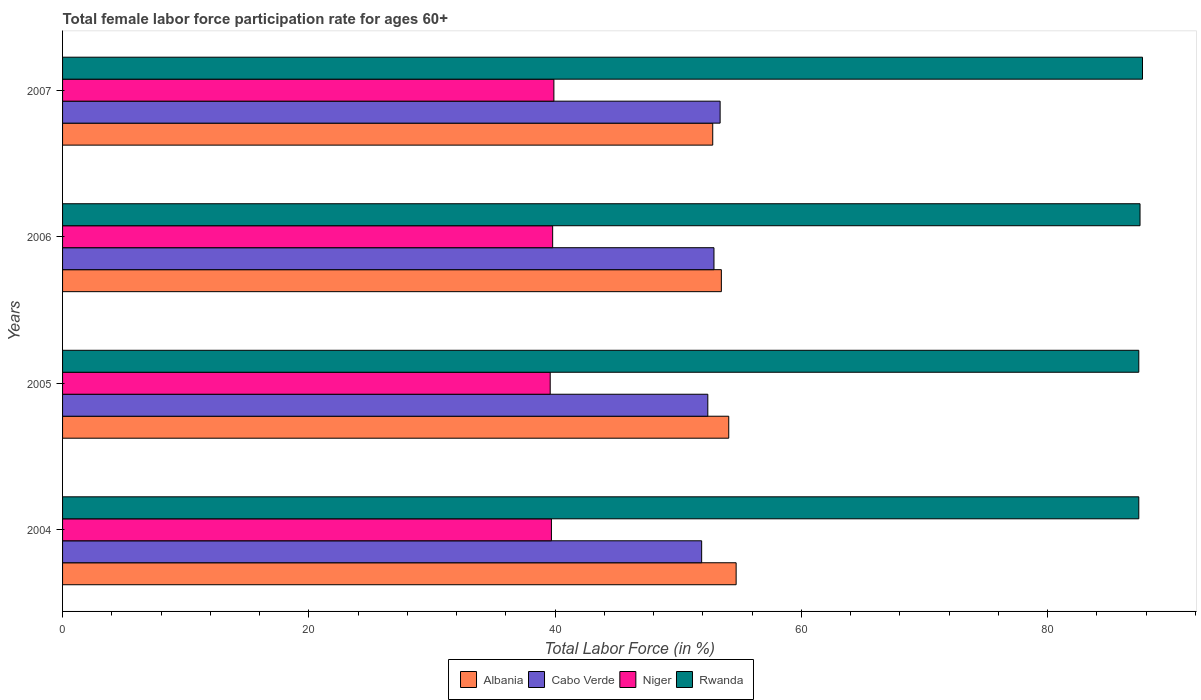How many groups of bars are there?
Your answer should be compact. 4. Are the number of bars on each tick of the Y-axis equal?
Provide a short and direct response. Yes. What is the female labor force participation rate in Cabo Verde in 2005?
Offer a very short reply. 52.4. Across all years, what is the maximum female labor force participation rate in Albania?
Your answer should be very brief. 54.7. Across all years, what is the minimum female labor force participation rate in Niger?
Ensure brevity in your answer.  39.6. In which year was the female labor force participation rate in Niger minimum?
Your response must be concise. 2005. What is the total female labor force participation rate in Rwanda in the graph?
Give a very brief answer. 350. What is the difference between the female labor force participation rate in Albania in 2005 and that in 2006?
Give a very brief answer. 0.6. What is the difference between the female labor force participation rate in Albania in 2004 and the female labor force participation rate in Rwanda in 2006?
Keep it short and to the point. -32.8. What is the average female labor force participation rate in Rwanda per year?
Keep it short and to the point. 87.5. In the year 2005, what is the difference between the female labor force participation rate in Niger and female labor force participation rate in Rwanda?
Offer a very short reply. -47.8. What is the ratio of the female labor force participation rate in Rwanda in 2006 to that in 2007?
Your response must be concise. 1. Is the female labor force participation rate in Niger in 2006 less than that in 2007?
Your response must be concise. Yes. What is the difference between the highest and the second highest female labor force participation rate in Niger?
Provide a short and direct response. 0.1. What is the difference between the highest and the lowest female labor force participation rate in Albania?
Make the answer very short. 1.9. Is it the case that in every year, the sum of the female labor force participation rate in Niger and female labor force participation rate in Rwanda is greater than the sum of female labor force participation rate in Albania and female labor force participation rate in Cabo Verde?
Your response must be concise. No. What does the 2nd bar from the top in 2006 represents?
Make the answer very short. Niger. What does the 2nd bar from the bottom in 2007 represents?
Ensure brevity in your answer.  Cabo Verde. Is it the case that in every year, the sum of the female labor force participation rate in Albania and female labor force participation rate in Cabo Verde is greater than the female labor force participation rate in Niger?
Offer a terse response. Yes. How many years are there in the graph?
Your response must be concise. 4. Does the graph contain grids?
Provide a succinct answer. No. Where does the legend appear in the graph?
Keep it short and to the point. Bottom center. How many legend labels are there?
Give a very brief answer. 4. What is the title of the graph?
Make the answer very short. Total female labor force participation rate for ages 60+. What is the label or title of the Y-axis?
Ensure brevity in your answer.  Years. What is the Total Labor Force (in %) in Albania in 2004?
Your answer should be compact. 54.7. What is the Total Labor Force (in %) of Cabo Verde in 2004?
Give a very brief answer. 51.9. What is the Total Labor Force (in %) of Niger in 2004?
Ensure brevity in your answer.  39.7. What is the Total Labor Force (in %) in Rwanda in 2004?
Provide a succinct answer. 87.4. What is the Total Labor Force (in %) of Albania in 2005?
Ensure brevity in your answer.  54.1. What is the Total Labor Force (in %) of Cabo Verde in 2005?
Provide a short and direct response. 52.4. What is the Total Labor Force (in %) of Niger in 2005?
Make the answer very short. 39.6. What is the Total Labor Force (in %) of Rwanda in 2005?
Give a very brief answer. 87.4. What is the Total Labor Force (in %) of Albania in 2006?
Give a very brief answer. 53.5. What is the Total Labor Force (in %) in Cabo Verde in 2006?
Your answer should be compact. 52.9. What is the Total Labor Force (in %) in Niger in 2006?
Your answer should be compact. 39.8. What is the Total Labor Force (in %) in Rwanda in 2006?
Provide a short and direct response. 87.5. What is the Total Labor Force (in %) of Albania in 2007?
Keep it short and to the point. 52.8. What is the Total Labor Force (in %) of Cabo Verde in 2007?
Your answer should be very brief. 53.4. What is the Total Labor Force (in %) in Niger in 2007?
Make the answer very short. 39.9. What is the Total Labor Force (in %) in Rwanda in 2007?
Give a very brief answer. 87.7. Across all years, what is the maximum Total Labor Force (in %) of Albania?
Give a very brief answer. 54.7. Across all years, what is the maximum Total Labor Force (in %) of Cabo Verde?
Your response must be concise. 53.4. Across all years, what is the maximum Total Labor Force (in %) of Niger?
Your response must be concise. 39.9. Across all years, what is the maximum Total Labor Force (in %) of Rwanda?
Make the answer very short. 87.7. Across all years, what is the minimum Total Labor Force (in %) of Albania?
Ensure brevity in your answer.  52.8. Across all years, what is the minimum Total Labor Force (in %) of Cabo Verde?
Offer a very short reply. 51.9. Across all years, what is the minimum Total Labor Force (in %) of Niger?
Offer a terse response. 39.6. Across all years, what is the minimum Total Labor Force (in %) of Rwanda?
Your response must be concise. 87.4. What is the total Total Labor Force (in %) in Albania in the graph?
Give a very brief answer. 215.1. What is the total Total Labor Force (in %) in Cabo Verde in the graph?
Offer a very short reply. 210.6. What is the total Total Labor Force (in %) in Niger in the graph?
Offer a very short reply. 159. What is the total Total Labor Force (in %) of Rwanda in the graph?
Keep it short and to the point. 350. What is the difference between the Total Labor Force (in %) of Cabo Verde in 2004 and that in 2005?
Provide a short and direct response. -0.5. What is the difference between the Total Labor Force (in %) in Rwanda in 2004 and that in 2005?
Keep it short and to the point. 0. What is the difference between the Total Labor Force (in %) in Niger in 2004 and that in 2006?
Provide a short and direct response. -0.1. What is the difference between the Total Labor Force (in %) in Cabo Verde in 2004 and that in 2007?
Your answer should be compact. -1.5. What is the difference between the Total Labor Force (in %) of Niger in 2004 and that in 2007?
Your answer should be compact. -0.2. What is the difference between the Total Labor Force (in %) of Albania in 2005 and that in 2007?
Your answer should be compact. 1.3. What is the difference between the Total Labor Force (in %) in Cabo Verde in 2006 and that in 2007?
Make the answer very short. -0.5. What is the difference between the Total Labor Force (in %) in Niger in 2006 and that in 2007?
Offer a very short reply. -0.1. What is the difference between the Total Labor Force (in %) of Albania in 2004 and the Total Labor Force (in %) of Niger in 2005?
Your answer should be compact. 15.1. What is the difference between the Total Labor Force (in %) in Albania in 2004 and the Total Labor Force (in %) in Rwanda in 2005?
Offer a terse response. -32.7. What is the difference between the Total Labor Force (in %) of Cabo Verde in 2004 and the Total Labor Force (in %) of Rwanda in 2005?
Offer a very short reply. -35.5. What is the difference between the Total Labor Force (in %) of Niger in 2004 and the Total Labor Force (in %) of Rwanda in 2005?
Provide a succinct answer. -47.7. What is the difference between the Total Labor Force (in %) of Albania in 2004 and the Total Labor Force (in %) of Cabo Verde in 2006?
Provide a succinct answer. 1.8. What is the difference between the Total Labor Force (in %) of Albania in 2004 and the Total Labor Force (in %) of Niger in 2006?
Your answer should be compact. 14.9. What is the difference between the Total Labor Force (in %) in Albania in 2004 and the Total Labor Force (in %) in Rwanda in 2006?
Your answer should be very brief. -32.8. What is the difference between the Total Labor Force (in %) in Cabo Verde in 2004 and the Total Labor Force (in %) in Niger in 2006?
Make the answer very short. 12.1. What is the difference between the Total Labor Force (in %) in Cabo Verde in 2004 and the Total Labor Force (in %) in Rwanda in 2006?
Make the answer very short. -35.6. What is the difference between the Total Labor Force (in %) in Niger in 2004 and the Total Labor Force (in %) in Rwanda in 2006?
Provide a short and direct response. -47.8. What is the difference between the Total Labor Force (in %) in Albania in 2004 and the Total Labor Force (in %) in Niger in 2007?
Offer a terse response. 14.8. What is the difference between the Total Labor Force (in %) in Albania in 2004 and the Total Labor Force (in %) in Rwanda in 2007?
Provide a succinct answer. -33. What is the difference between the Total Labor Force (in %) of Cabo Verde in 2004 and the Total Labor Force (in %) of Rwanda in 2007?
Your answer should be very brief. -35.8. What is the difference between the Total Labor Force (in %) of Niger in 2004 and the Total Labor Force (in %) of Rwanda in 2007?
Give a very brief answer. -48. What is the difference between the Total Labor Force (in %) in Albania in 2005 and the Total Labor Force (in %) in Rwanda in 2006?
Offer a very short reply. -33.4. What is the difference between the Total Labor Force (in %) of Cabo Verde in 2005 and the Total Labor Force (in %) of Niger in 2006?
Keep it short and to the point. 12.6. What is the difference between the Total Labor Force (in %) in Cabo Verde in 2005 and the Total Labor Force (in %) in Rwanda in 2006?
Ensure brevity in your answer.  -35.1. What is the difference between the Total Labor Force (in %) of Niger in 2005 and the Total Labor Force (in %) of Rwanda in 2006?
Provide a succinct answer. -47.9. What is the difference between the Total Labor Force (in %) of Albania in 2005 and the Total Labor Force (in %) of Niger in 2007?
Your answer should be very brief. 14.2. What is the difference between the Total Labor Force (in %) in Albania in 2005 and the Total Labor Force (in %) in Rwanda in 2007?
Offer a terse response. -33.6. What is the difference between the Total Labor Force (in %) of Cabo Verde in 2005 and the Total Labor Force (in %) of Niger in 2007?
Offer a very short reply. 12.5. What is the difference between the Total Labor Force (in %) of Cabo Verde in 2005 and the Total Labor Force (in %) of Rwanda in 2007?
Provide a short and direct response. -35.3. What is the difference between the Total Labor Force (in %) in Niger in 2005 and the Total Labor Force (in %) in Rwanda in 2007?
Your answer should be compact. -48.1. What is the difference between the Total Labor Force (in %) of Albania in 2006 and the Total Labor Force (in %) of Niger in 2007?
Give a very brief answer. 13.6. What is the difference between the Total Labor Force (in %) in Albania in 2006 and the Total Labor Force (in %) in Rwanda in 2007?
Your answer should be very brief. -34.2. What is the difference between the Total Labor Force (in %) of Cabo Verde in 2006 and the Total Labor Force (in %) of Rwanda in 2007?
Keep it short and to the point. -34.8. What is the difference between the Total Labor Force (in %) in Niger in 2006 and the Total Labor Force (in %) in Rwanda in 2007?
Provide a succinct answer. -47.9. What is the average Total Labor Force (in %) of Albania per year?
Your answer should be very brief. 53.77. What is the average Total Labor Force (in %) in Cabo Verde per year?
Offer a very short reply. 52.65. What is the average Total Labor Force (in %) in Niger per year?
Your answer should be very brief. 39.75. What is the average Total Labor Force (in %) of Rwanda per year?
Give a very brief answer. 87.5. In the year 2004, what is the difference between the Total Labor Force (in %) of Albania and Total Labor Force (in %) of Rwanda?
Ensure brevity in your answer.  -32.7. In the year 2004, what is the difference between the Total Labor Force (in %) of Cabo Verde and Total Labor Force (in %) of Niger?
Your response must be concise. 12.2. In the year 2004, what is the difference between the Total Labor Force (in %) of Cabo Verde and Total Labor Force (in %) of Rwanda?
Provide a short and direct response. -35.5. In the year 2004, what is the difference between the Total Labor Force (in %) of Niger and Total Labor Force (in %) of Rwanda?
Give a very brief answer. -47.7. In the year 2005, what is the difference between the Total Labor Force (in %) in Albania and Total Labor Force (in %) in Cabo Verde?
Offer a very short reply. 1.7. In the year 2005, what is the difference between the Total Labor Force (in %) of Albania and Total Labor Force (in %) of Niger?
Provide a succinct answer. 14.5. In the year 2005, what is the difference between the Total Labor Force (in %) of Albania and Total Labor Force (in %) of Rwanda?
Your response must be concise. -33.3. In the year 2005, what is the difference between the Total Labor Force (in %) in Cabo Verde and Total Labor Force (in %) in Rwanda?
Your answer should be compact. -35. In the year 2005, what is the difference between the Total Labor Force (in %) of Niger and Total Labor Force (in %) of Rwanda?
Provide a succinct answer. -47.8. In the year 2006, what is the difference between the Total Labor Force (in %) in Albania and Total Labor Force (in %) in Rwanda?
Provide a succinct answer. -34. In the year 2006, what is the difference between the Total Labor Force (in %) of Cabo Verde and Total Labor Force (in %) of Rwanda?
Give a very brief answer. -34.6. In the year 2006, what is the difference between the Total Labor Force (in %) in Niger and Total Labor Force (in %) in Rwanda?
Ensure brevity in your answer.  -47.7. In the year 2007, what is the difference between the Total Labor Force (in %) of Albania and Total Labor Force (in %) of Niger?
Make the answer very short. 12.9. In the year 2007, what is the difference between the Total Labor Force (in %) in Albania and Total Labor Force (in %) in Rwanda?
Give a very brief answer. -34.9. In the year 2007, what is the difference between the Total Labor Force (in %) in Cabo Verde and Total Labor Force (in %) in Rwanda?
Your response must be concise. -34.3. In the year 2007, what is the difference between the Total Labor Force (in %) of Niger and Total Labor Force (in %) of Rwanda?
Your response must be concise. -47.8. What is the ratio of the Total Labor Force (in %) of Albania in 2004 to that in 2005?
Ensure brevity in your answer.  1.01. What is the ratio of the Total Labor Force (in %) of Niger in 2004 to that in 2005?
Your response must be concise. 1. What is the ratio of the Total Labor Force (in %) in Albania in 2004 to that in 2006?
Offer a terse response. 1.02. What is the ratio of the Total Labor Force (in %) in Cabo Verde in 2004 to that in 2006?
Your response must be concise. 0.98. What is the ratio of the Total Labor Force (in %) of Albania in 2004 to that in 2007?
Your answer should be very brief. 1.04. What is the ratio of the Total Labor Force (in %) in Cabo Verde in 2004 to that in 2007?
Give a very brief answer. 0.97. What is the ratio of the Total Labor Force (in %) of Albania in 2005 to that in 2006?
Give a very brief answer. 1.01. What is the ratio of the Total Labor Force (in %) of Cabo Verde in 2005 to that in 2006?
Provide a short and direct response. 0.99. What is the ratio of the Total Labor Force (in %) in Albania in 2005 to that in 2007?
Keep it short and to the point. 1.02. What is the ratio of the Total Labor Force (in %) of Cabo Verde in 2005 to that in 2007?
Ensure brevity in your answer.  0.98. What is the ratio of the Total Labor Force (in %) of Albania in 2006 to that in 2007?
Offer a very short reply. 1.01. What is the ratio of the Total Labor Force (in %) in Cabo Verde in 2006 to that in 2007?
Ensure brevity in your answer.  0.99. What is the ratio of the Total Labor Force (in %) in Niger in 2006 to that in 2007?
Ensure brevity in your answer.  1. What is the difference between the highest and the second highest Total Labor Force (in %) of Cabo Verde?
Provide a succinct answer. 0.5. What is the difference between the highest and the second highest Total Labor Force (in %) of Niger?
Your response must be concise. 0.1. What is the difference between the highest and the lowest Total Labor Force (in %) in Albania?
Keep it short and to the point. 1.9. What is the difference between the highest and the lowest Total Labor Force (in %) of Niger?
Your answer should be very brief. 0.3. 